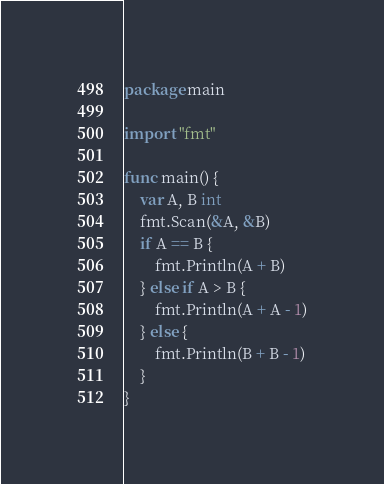Convert code to text. <code><loc_0><loc_0><loc_500><loc_500><_Go_>package main

import "fmt"

func main() {
	var A, B int
	fmt.Scan(&A, &B)
	if A == B {
		fmt.Println(A + B)
	} else if A > B {
		fmt.Println(A + A - 1)
	} else {
		fmt.Println(B + B - 1)
	}
}
</code> 